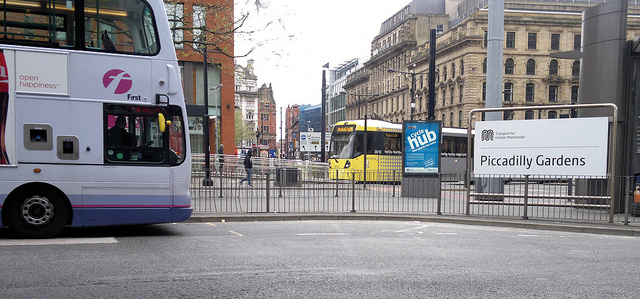How many buses are there? There are two buses visible in the image, each of different colors and potentially different bus lines, indicating a busy urban transportation hub. 